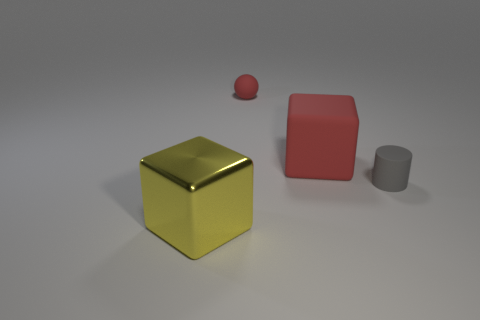Subtract all green balls. Subtract all purple blocks. How many balls are left? 1 Add 4 small gray cylinders. How many objects exist? 8 Subtract all balls. How many objects are left? 3 Add 3 big red cubes. How many big red cubes exist? 4 Subtract 0 purple cylinders. How many objects are left? 4 Subtract all tiny gray matte cylinders. Subtract all small red rubber balls. How many objects are left? 2 Add 3 gray matte cylinders. How many gray matte cylinders are left? 4 